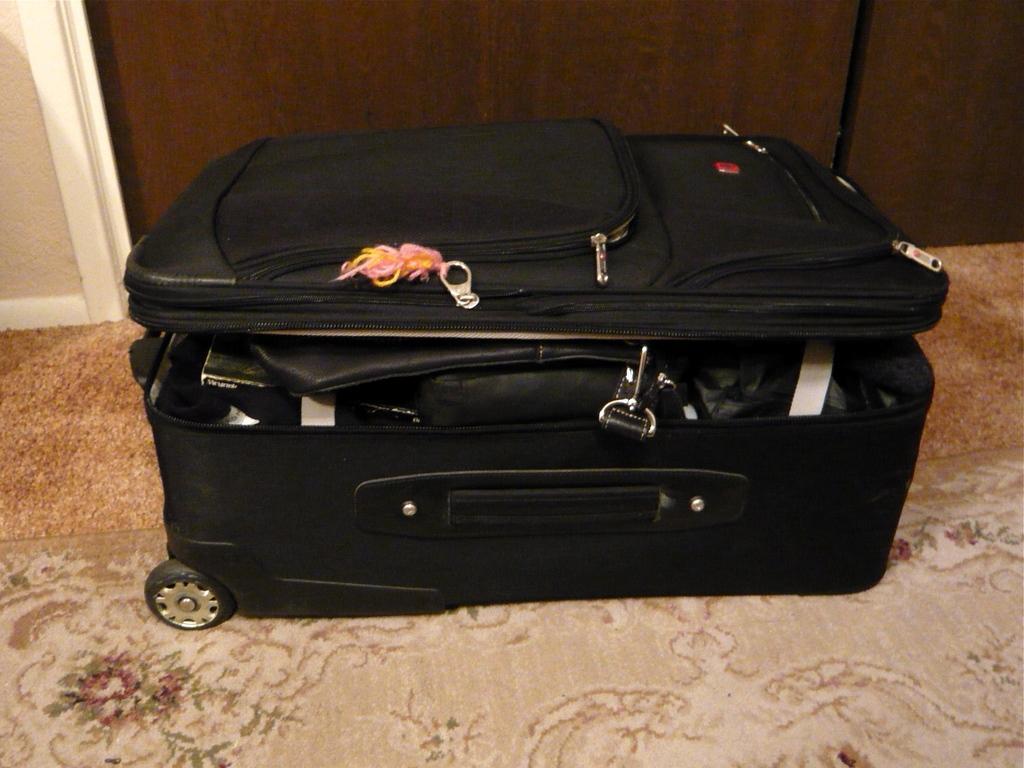Describe this image in one or two sentences. In the picture we can find a suitcase it has a wheel, handle, lock and some files in it. And it is placed on the carpet floor. In the background we can find a wooden wall. 